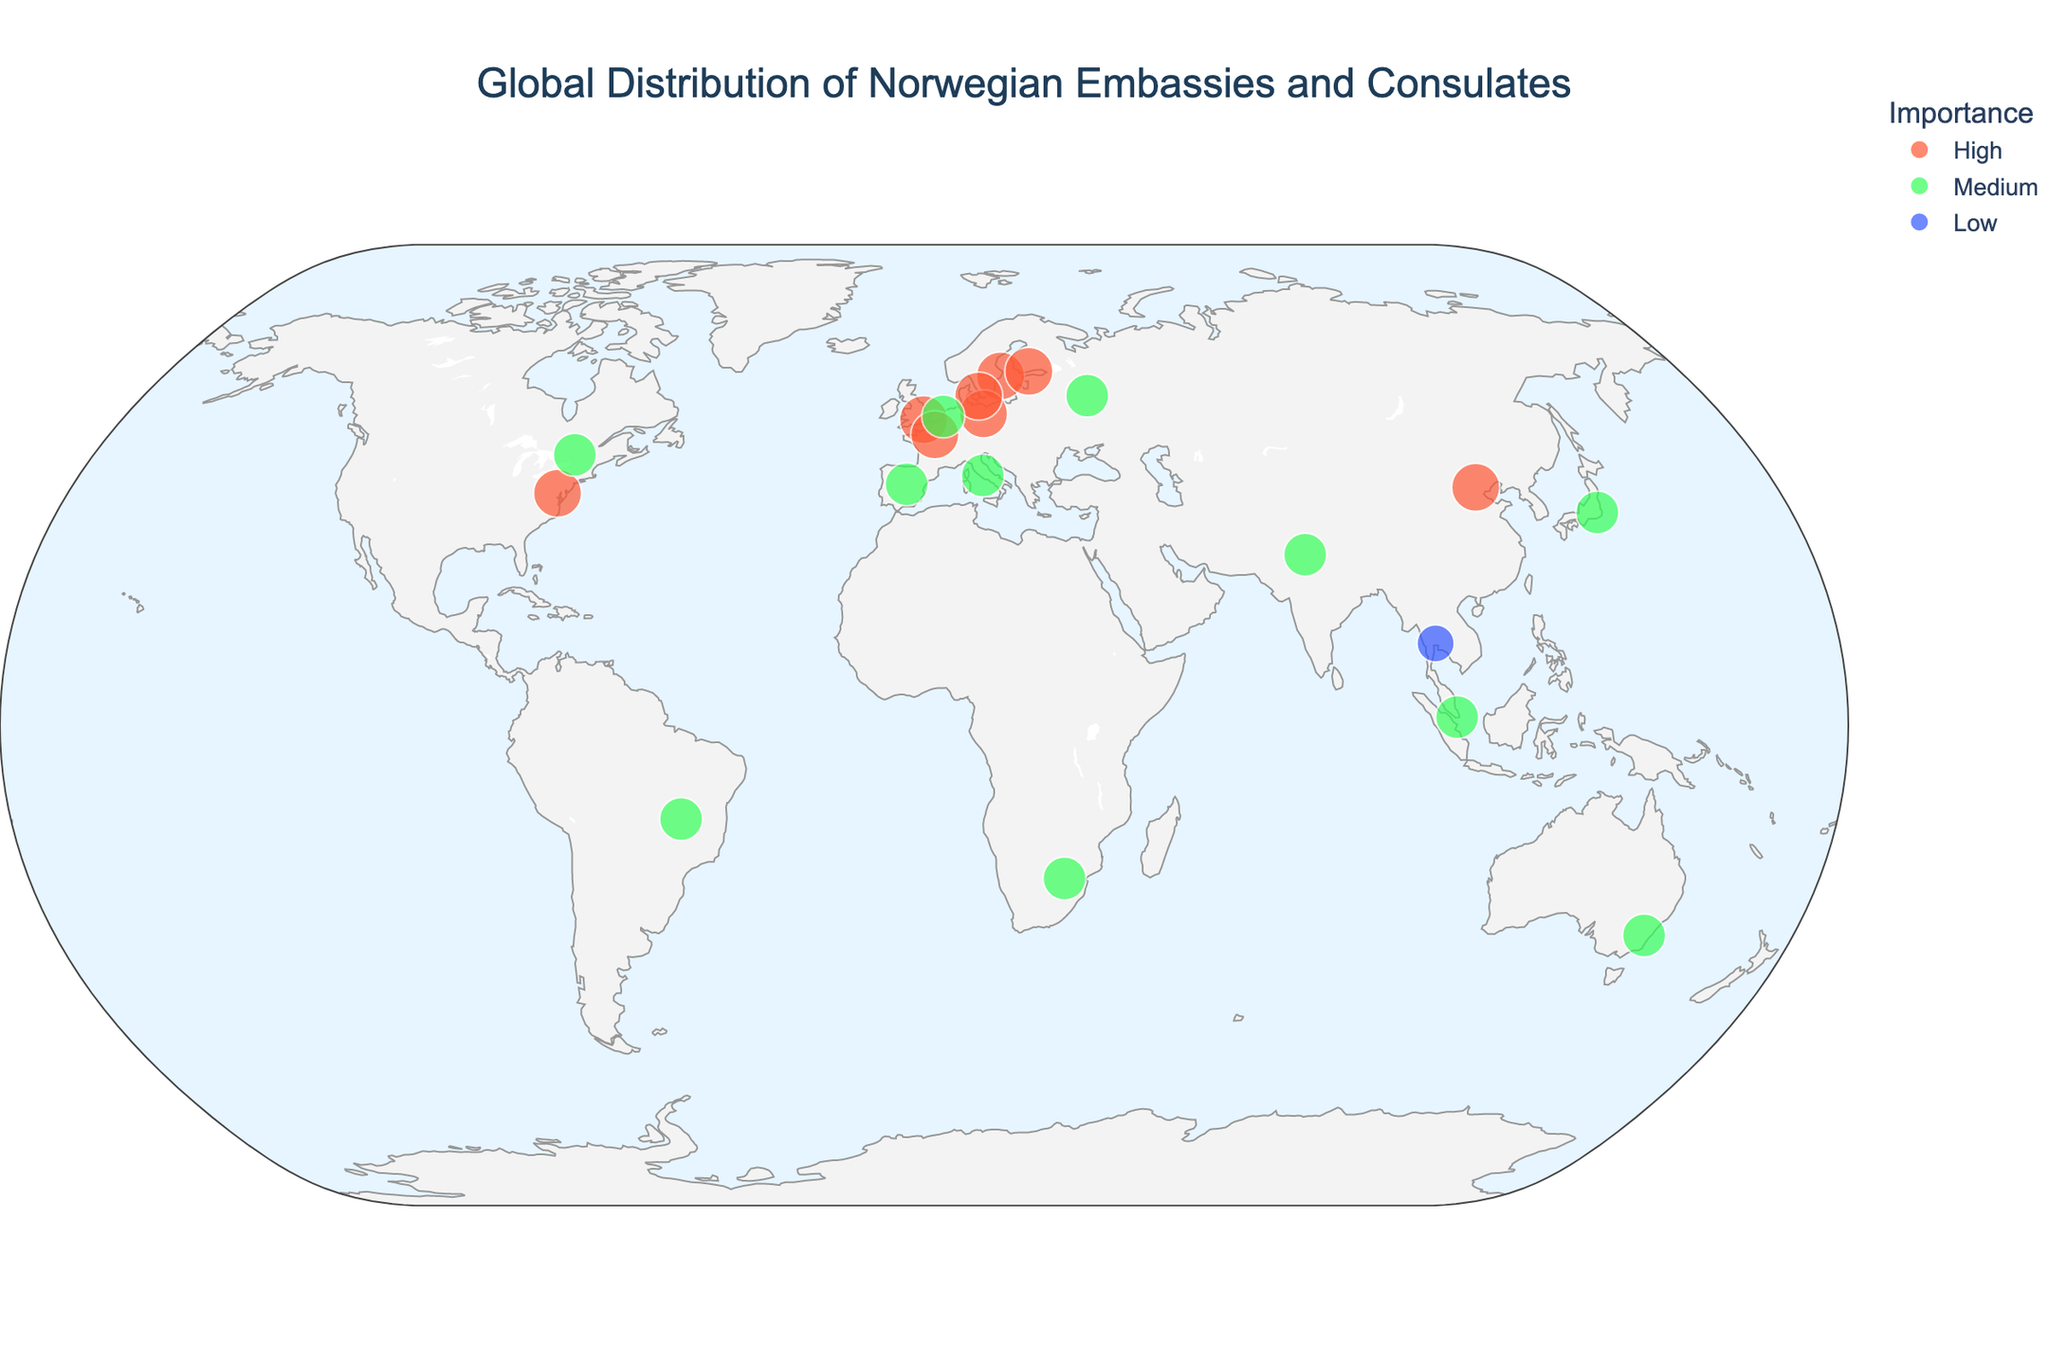What is the title of the map? The title of the map is displayed at the top center of the figure, which provides a brief description of what the map represents. The title in this case reads "Global Distribution of Norwegian Embassies and Consulates".
Answer: Global Distribution of Norwegian Embassies and Consulates How many types of diplomatic missions are represented on the map? By inspecting the hover data or legend, we see that there are two types of diplomatic missions highlighted: Embassies and Consulates.
Answer: Two Which countries have 'High' importance for Norwegian embassies? To determine this, look at the legend where the color associated with 'High' importance is indicated, and then identify the countries marked with this color on the map. These countries are Sweden, United States, Germany, United Kingdom, France, and Denmark.
Answer: Sweden, United States, Germany, United Kingdom, France, Denmark What city has a Norwegian Consulate with 'Low' importance? By examining the map and hover data, you can identify that Bangkok in Thailand is the city with a Norwegian consulate marked with 'Low' importance.
Answer: Bangkok Which continents have the highest concentration of Norwegian embassies? By observing the geographic spread of the markers, Europe has the highest concentration of Norwegian embassies indicated by multiple markers within close proximity.
Answer: Europe How many Norwegian embassies are marked with 'Medium' importance? By counting the markers colored according to 'Medium' importance, there are 11 Norwegian embassies in this category. These include Singapore, Japan, Brazil, South Africa, Russia, Australia, Canada, India, Spain, Italy, and Netherlands.
Answer: 11 What is the total number of Norwegian diplomatic missions shown on the map? By counting all the markers regardless of the type and importance, there are 19 Norwegian diplomatic missions (embassies and consulates) displayed on the map.
Answer: 19 Which embassy is closest to the equator? The city closest to the equator can be identified by its latitude value. Singapore, with an approximate latitude of 1.3521, is the nearest to the equator.
Answer: Singapore Compare the number of embassies in North America to Europe. By counting the markers, North America has 3 embassies (United States and Canada), while Europe has 9 embassies (Sweden, Germany, United Kingdom, France, Denmark, Finland, Italy, Netherlands, and Spain).
Answer: Europe has more embassies than North America What is the importance of the Norwegian diplomatic mission in Brazil? Observing the color code associated with the geographic marker for Brazil on the map, Brasilia has a Norwegian embassy with 'Medium' importance.
Answer: Medium 